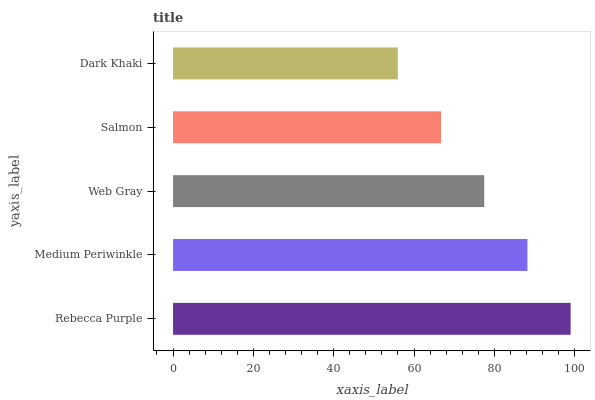Is Dark Khaki the minimum?
Answer yes or no. Yes. Is Rebecca Purple the maximum?
Answer yes or no. Yes. Is Medium Periwinkle the minimum?
Answer yes or no. No. Is Medium Periwinkle the maximum?
Answer yes or no. No. Is Rebecca Purple greater than Medium Periwinkle?
Answer yes or no. Yes. Is Medium Periwinkle less than Rebecca Purple?
Answer yes or no. Yes. Is Medium Periwinkle greater than Rebecca Purple?
Answer yes or no. No. Is Rebecca Purple less than Medium Periwinkle?
Answer yes or no. No. Is Web Gray the high median?
Answer yes or no. Yes. Is Web Gray the low median?
Answer yes or no. Yes. Is Rebecca Purple the high median?
Answer yes or no. No. Is Rebecca Purple the low median?
Answer yes or no. No. 